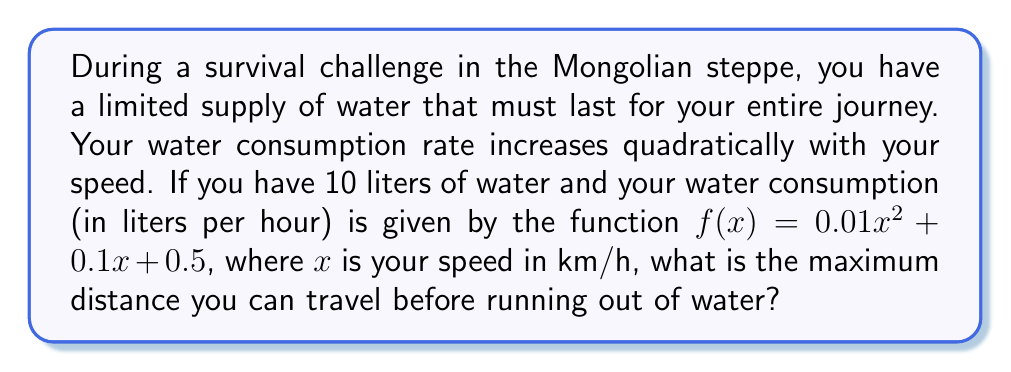Provide a solution to this math problem. To solve this problem, we need to follow these steps:

1) First, we need to find the time it takes to consume all the water. Let's call this time $t$. We can express the total water consumed as the product of the consumption rate and time:

   $10 = (0.01x^2 + 0.1x + 0.5)t$

2) Now, we need to express the distance traveled. Distance is the product of speed and time:

   $d = xt$

3) From step 1, we can express $t$ in terms of $x$:

   $t = \frac{10}{0.01x^2 + 0.1x + 0.5}$

4) Substituting this into our distance equation:

   $d = x \cdot \frac{10}{0.01x^2 + 0.1x + 0.5}$

5) Simplify:

   $d = \frac{10x}{0.01x^2 + 0.1x + 0.5}$

6) To find the maximum distance, we need to find the critical points of this function. We can do this by taking the derivative and setting it equal to zero:

   $\frac{d}{dx}d = \frac{10(0.01x^2 + 0.1x + 0.5) - 10x(0.02x + 0.1)}{(0.01x^2 + 0.1x + 0.5)^2} = 0$

7) Simplify the numerator:

   $10(0.01x^2 + 0.1x + 0.5) - 10x(0.02x + 0.1) = 0$
   $0.1x^2 + x + 5 - 0.2x^2 - x = 0$
   $-0.1x^2 + 5 = 0$

8) Solve for $x$:

   $x^2 = 50$
   $x = \sqrt{50} = 5\sqrt{2} \approx 7.07$ km/h

9) This is the speed that maximizes distance. To find the maximum distance, plug this back into our distance equation:

   $d_{max} = \frac{10(5\sqrt{2})}{0.01(5\sqrt{2})^2 + 0.1(5\sqrt{2}) + 0.5}$
Answer: The maximum distance traveled is approximately 70.71 km when traveling at a speed of 7.07 km/h. 